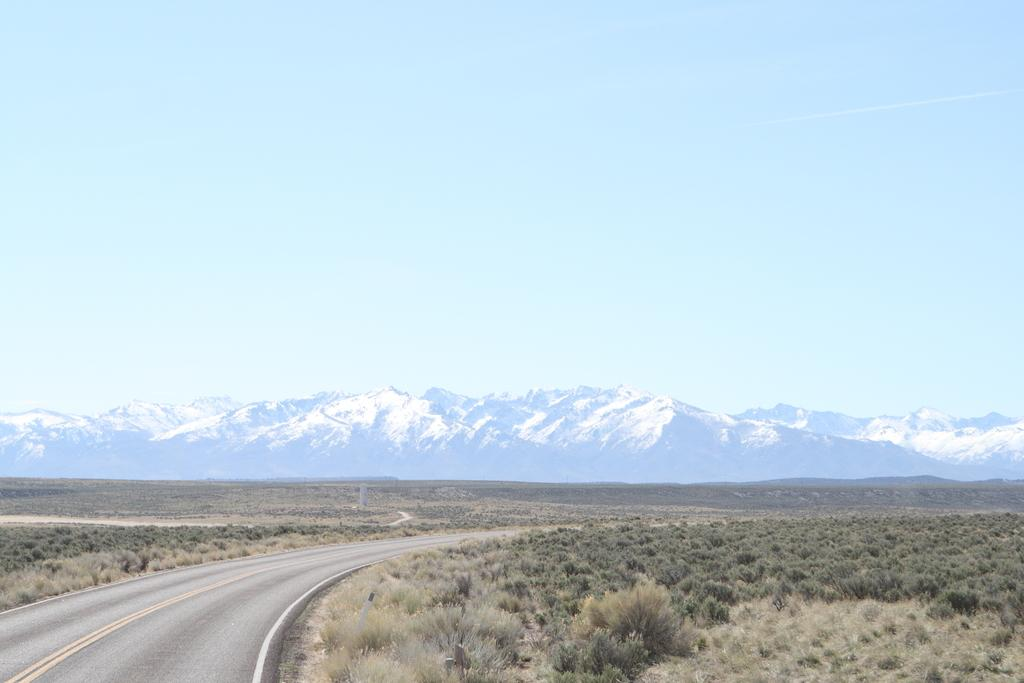What type of natural elements can be seen on the ground in the image? There are trees and plants on the ground in the image. What type of man-made structure is visible in the image? There is a road visible in the image. What type of geographical feature can be seen in the distance in the image? There are mountains in the image. How would you describe the sky in the image? The sky is blue and cloudy in the image. Can you see the smile on the beetle's face in the image? There are no beetles or faces present in the image, so it is not possible to see a smile on a beetle's face. 